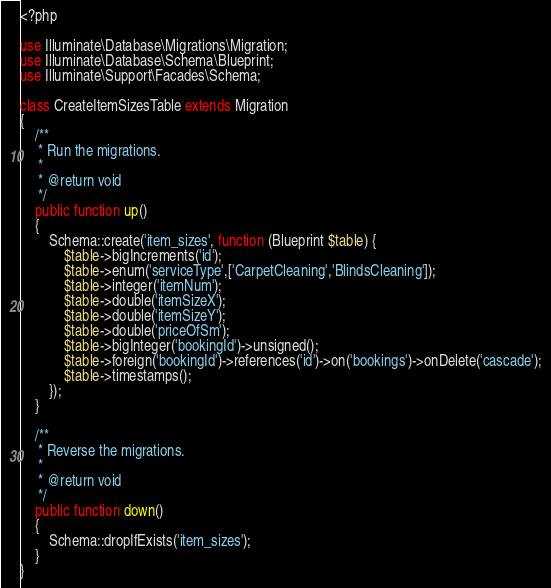<code> <loc_0><loc_0><loc_500><loc_500><_PHP_><?php

use Illuminate\Database\Migrations\Migration;
use Illuminate\Database\Schema\Blueprint;
use Illuminate\Support\Facades\Schema;

class CreateItemSizesTable extends Migration
{
    /**
     * Run the migrations.
     *
     * @return void
     */
    public function up()
    {
        Schema::create('item_sizes', function (Blueprint $table) {
            $table->bigIncrements('id');
            $table->enum('serviceType',['CarpetCleaning','BlindsCleaning']);
            $table->integer('itemNum');
            $table->double('itemSizeX');
            $table->double('itemSizeY');
            $table->double('priceOfSm');
            $table->bigInteger('bookingId')->unsigned();
            $table->foreign('bookingId')->references('id')->on('bookings')->onDelete('cascade');
            $table->timestamps();
        });
    }

    /**
     * Reverse the migrations.
     *
     * @return void
     */
    public function down()
    {
        Schema::dropIfExists('item_sizes');
    }
}
</code> 